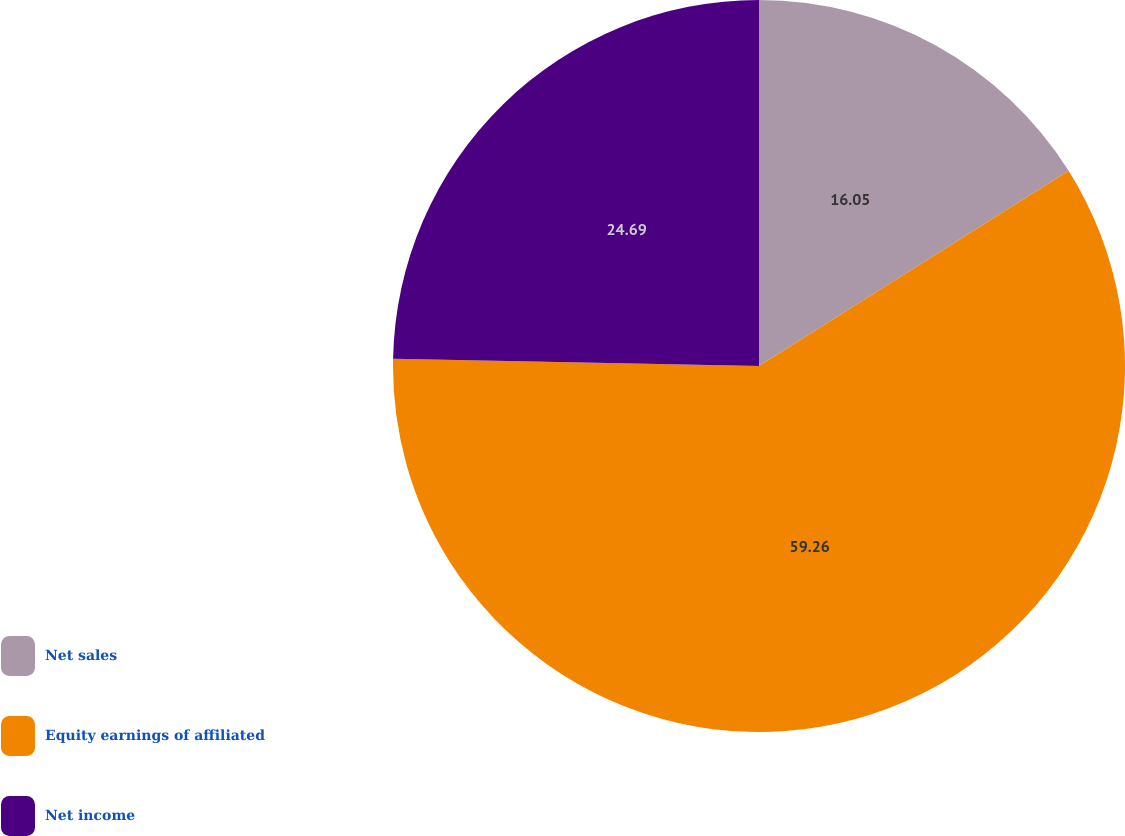Convert chart to OTSL. <chart><loc_0><loc_0><loc_500><loc_500><pie_chart><fcel>Net sales<fcel>Equity earnings of affiliated<fcel>Net income<nl><fcel>16.05%<fcel>59.26%<fcel>24.69%<nl></chart> 